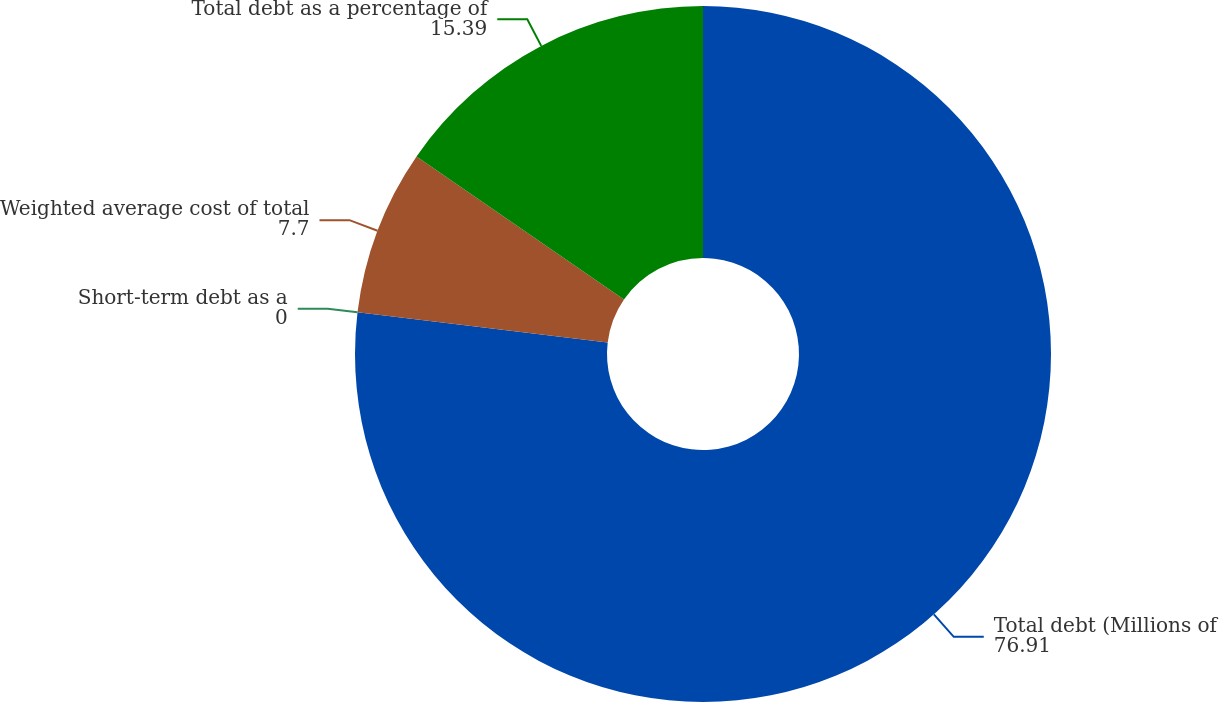Convert chart to OTSL. <chart><loc_0><loc_0><loc_500><loc_500><pie_chart><fcel>Total debt (Millions of<fcel>Short-term debt as a<fcel>Weighted average cost of total<fcel>Total debt as a percentage of<nl><fcel>76.91%<fcel>0.0%<fcel>7.7%<fcel>15.39%<nl></chart> 